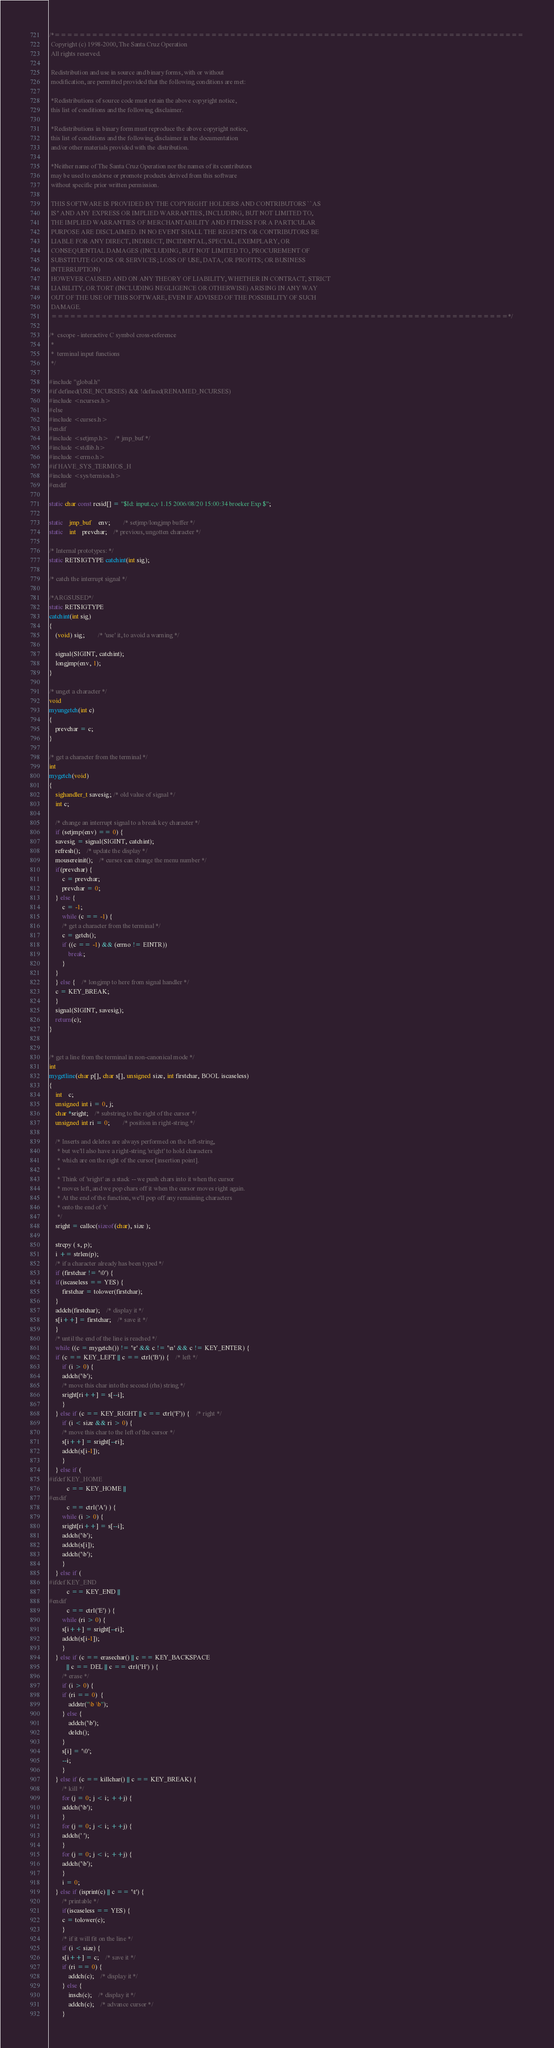<code> <loc_0><loc_0><loc_500><loc_500><_C_>/*===========================================================================
 Copyright (c) 1998-2000, The Santa Cruz Operation 
 All rights reserved.
 
 Redistribution and use in source and binary forms, with or without
 modification, are permitted provided that the following conditions are met:

 *Redistributions of source code must retain the above copyright notice,
 this list of conditions and the following disclaimer.

 *Redistributions in binary form must reproduce the above copyright notice,
 this list of conditions and the following disclaimer in the documentation
 and/or other materials provided with the distribution.

 *Neither name of The Santa Cruz Operation nor the names of its contributors
 may be used to endorse or promote products derived from this software
 without specific prior written permission. 

 THIS SOFTWARE IS PROVIDED BY THE COPYRIGHT HOLDERS AND CONTRIBUTORS ``AS
 IS'' AND ANY EXPRESS OR IMPLIED WARRANTIES, INCLUDING, BUT NOT LIMITED TO,
 THE IMPLIED WARRANTIES OF MERCHANTABILITY AND FITNESS FOR A PARTICULAR
 PURPOSE ARE DISCLAIMED. IN NO EVENT SHALL THE REGENTS OR CONTRIBUTORS BE
 LIABLE FOR ANY DIRECT, INDIRECT, INCIDENTAL, SPECIAL, EXEMPLARY, OR
 CONSEQUENTIAL DAMAGES (INCLUDING, BUT NOT LIMITED TO, PROCUREMENT OF
 SUBSTITUTE GOODS OR SERVICES; LOSS OF USE, DATA, OR PROFITS; OR BUSINESS
 INTERRUPTION)
 HOWEVER CAUSED AND ON ANY THEORY OF LIABILITY, WHETHER IN CONTRACT, STRICT
 LIABILITY, OR TORT (INCLUDING NEGLIGENCE OR OTHERWISE) ARISING IN ANY WAY
 OUT OF THE USE OF THIS SOFTWARE, EVEN IF ADVISED OF THE POSSIBILITY OF SUCH
 DAMAGE. 
 =========================================================================*/

/*	cscope - interactive C symbol cross-reference
 *
 *	terminal input functions
 */

#include "global.h"
#if defined(USE_NCURSES) && !defined(RENAMED_NCURSES)
#include <ncurses.h>
#else
#include <curses.h>
#endif
#include <setjmp.h>	/* jmp_buf */
#include <stdlib.h>
#include <errno.h>
#if HAVE_SYS_TERMIOS_H
#include <sys/termios.h>
#endif

static char const rcsid[] = "$Id: input.c,v 1.15 2006/08/20 15:00:34 broeker Exp $";

static	jmp_buf	env;		/* setjmp/longjmp buffer */
static	int	prevchar;	/* previous, ungotten character */

/* Internal prototypes: */
static RETSIGTYPE catchint(int sig);

/* catch the interrupt signal */

/*ARGSUSED*/
static RETSIGTYPE
catchint(int sig)
{
 	(void) sig;		/* 'use' it, to avoid a warning */

	signal(SIGINT, catchint);
	longjmp(env, 1);
}

/* unget a character */
void
myungetch(int c)
{
	prevchar = c;
}

/* get a character from the terminal */
int
mygetch(void)
{
    sighandler_t savesig; /* old value of signal */
    int c;

    /* change an interrupt signal to a break key character */
    if (setjmp(env) == 0) {
	savesig = signal(SIGINT, catchint);
	refresh();	/* update the display */
	mousereinit();	/* curses can change the menu number */
	if(prevchar) {
	    c = prevchar;
	    prevchar = 0;
	} else {
	    c = -1;
	    while (c == -1) {
		/* get a character from the terminal */
		c = getch();
		if ((c == -1) && (errno != EINTR))
		    break;
	    }
	}
    } else {	/* longjmp to here from signal handler */
	c = KEY_BREAK;
    }
    signal(SIGINT, savesig);
    return(c);
}


/* get a line from the terminal in non-canonical mode */
int
mygetline(char p[], char s[], unsigned size, int firstchar, BOOL iscaseless)
{
    int	c;
    unsigned int i = 0, j;
    char *sright;	/* substring to the right of the cursor */
    unsigned int ri = 0;		/* position in right-string */

    /* Inserts and deletes are always performed on the left-string,
     * but we'll also have a right-string 'sright' to hold characters
     * which are on the right of the cursor [insertion point].
     *
     * Think of 'sright' as a stack -- we push chars into it when the cursor
     * moves left, and we pop chars off it when the cursor moves right again.
     * At the end of the function, we'll pop off any remaining characters
     * onto the end of 's'
     */
    sright = calloc(sizeof(char), size );

    strcpy ( s, p);
    i += strlen(p);
    /* if a character already has been typed */
    if (firstchar != '\0') {
	if(iscaseless == YES) {
	    firstchar = tolower(firstchar);
	}
	addch(firstchar);	/* display it */
	s[i++] = firstchar;	/* save it */
    }
    /* until the end of the line is reached */
    while ((c = mygetch()) != '\r' && c != '\n' && c != KEY_ENTER) {
	if (c == KEY_LEFT || c == ctrl('B')) {	/* left */
	    if (i > 0) {
		addch('\b');
		/* move this char into the second (rhs) string */
		sright[ri++] = s[--i];
	    }
	} else if (c == KEY_RIGHT || c == ctrl('F')) {	/* right */
	    if (i < size && ri > 0) {
		/* move this char to the left of the cursor */
		s[i++] = sright[--ri];
		addch(s[i-1]);
	    }
	} else if (
#ifdef KEY_HOME
		   c == KEY_HOME ||
#endif
		   c == ctrl('A') ) {
	    while (i > 0) {
		sright[ri++] = s[--i];
		addch('\b');
		addch(s[i]);
		addch('\b');
	    }
	} else if (
#ifdef KEY_END
		   c == KEY_END ||
#endif
		   c == ctrl('E') ) {
	    while (ri > 0) {
		s[i++] = sright[--ri];
		addch(s[i-1]);
	    }
	} else if (c == erasechar() || c == KEY_BACKSPACE
		   || c == DEL || c == ctrl('H') ) {
	    /* erase */
	    if (i > 0) {
		if (ri == 0)  {
		    addstr("\b \b");
		} else {
		    addch('\b');
		    delch();
		}
		s[i] = '\0';
		--i;
	    }
	} else if (c == killchar() || c == KEY_BREAK) {
	    /* kill */
	    for (j = 0; j < i; ++j) {
		addch('\b');
	    }
	    for (j = 0; j < i; ++j) {
		addch(' ');
	    }
	    for (j = 0; j < i; ++j) {
		addch('\b');
	    }
	    i = 0;
	} else if (isprint(c) || c == '\t') {
	    /* printable */
	    if(iscaseless == YES) {
		c = tolower(c);
	    }
	    /* if it will fit on the line */
	    if (i < size) {
		s[i++] = c;	/* save it */
		if (ri == 0) {
		    addch(c);	/* display it */
		} else {
		    insch(c);	/* display it */
		    addch(c);	/* advance cursor */
		}</code> 